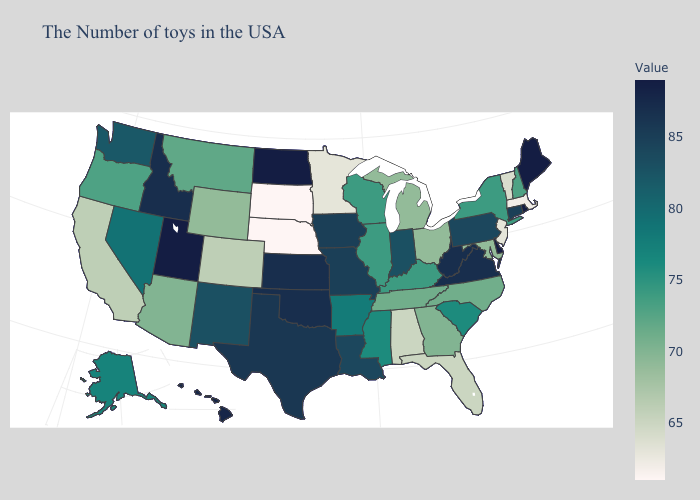Does Connecticut have the lowest value in the USA?
Concise answer only. No. Does New Jersey have a higher value than Idaho?
Answer briefly. No. Among the states that border Connecticut , which have the lowest value?
Write a very short answer. Massachusetts. Does South Dakota have the lowest value in the USA?
Concise answer only. Yes. 